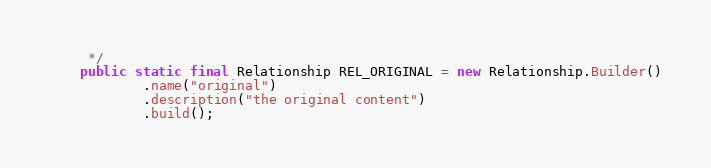<code> <loc_0><loc_0><loc_500><loc_500><_Java_>     */
    public static final Relationship REL_ORIGINAL = new Relationship.Builder()
            .name("original")
            .description("the original content")
            .build();
</code> 